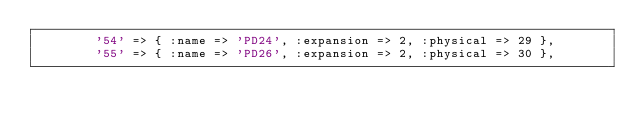<code> <loc_0><loc_0><loc_500><loc_500><_Ruby_>        '54' => { :name => 'PD24', :expansion => 2, :physical => 29 },
        '55' => { :name => 'PD26', :expansion => 2, :physical => 30 },</code> 